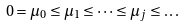<formula> <loc_0><loc_0><loc_500><loc_500>0 = \mu _ { 0 } \leq \mu _ { 1 } \leq \dots \leq \mu _ { j } \leq \dots</formula> 